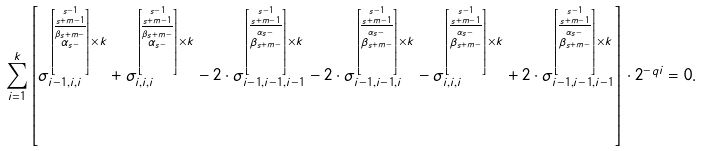Convert formula to latex. <formula><loc_0><loc_0><loc_500><loc_500>\sum _ { i = 1 } ^ { k } \left [ \sigma _ { i - 1 , i , i } ^ { \left [ \stackrel { s - 1 } { \stackrel { s + m - 1 } { \overline { \stackrel { \beta _ { s + m - } } { \alpha _ { s - } } } } } \right ] \times k } + \sigma _ { i , i , i } ^ { \left [ \stackrel { s - 1 } { \stackrel { s + m - 1 } { \overline { \stackrel { \beta _ { s + m - } } { \alpha _ { s - } } } } } \right ] \times k } - 2 \cdot \sigma _ { i - 1 , i - 1 , i - 1 } ^ { \left [ \stackrel { s - 1 } { \stackrel { s + m - 1 } { \overline { \stackrel { \alpha _ { s - } } { \beta _ { s + m - } } } } } \right ] \times k } - 2 \cdot \sigma _ { i - 1 , i - 1 , i } ^ { \left [ \stackrel { s - 1 } { \stackrel { s + m - 1 } { \overline { \stackrel { \alpha _ { s - } } { \beta _ { s + m - } } } } } \right ] \times k } - \sigma _ { i , i , i } ^ { \left [ \stackrel { s - 1 } { \stackrel { s + m - 1 } { \overline { \stackrel { \alpha _ { s - } } { \beta _ { s + m - } } } } } \right ] \times k } + 2 \cdot \sigma _ { i - 1 , i - 1 , i - 1 } ^ { \left [ \stackrel { s - 1 } { \stackrel { s + m - 1 } { \overline { \stackrel { \alpha _ { s - } } { \beta _ { s + m - } } } } } \right ] \times k } \right ] \cdot 2 ^ { - q i } = 0 .</formula> 